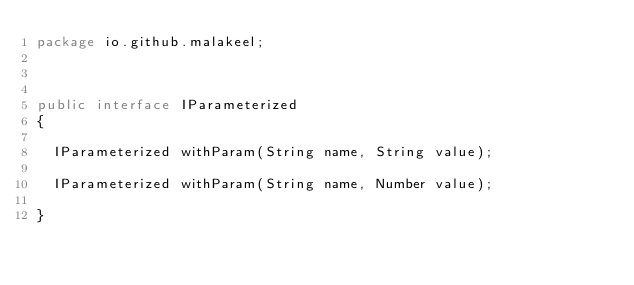Convert code to text. <code><loc_0><loc_0><loc_500><loc_500><_Java_>package io.github.malakeel;



public interface IParameterized
{

	IParameterized withParam(String name, String value);

	IParameterized withParam(String name, Number value);

}
</code> 